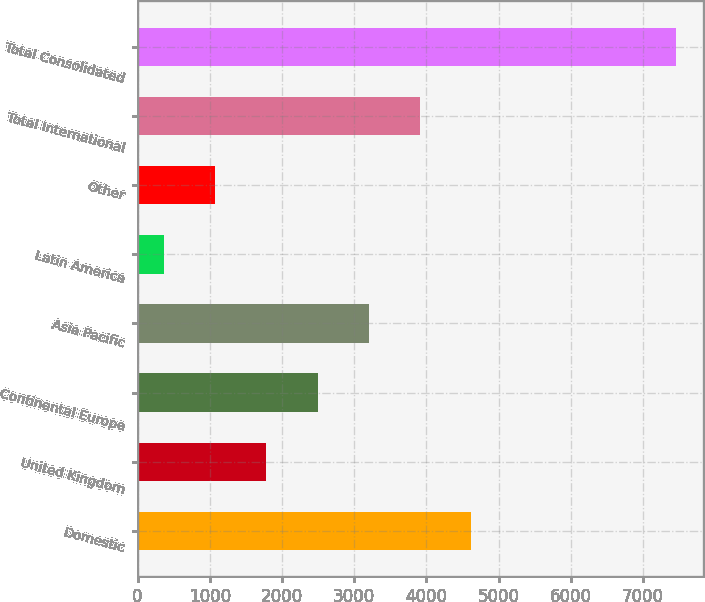Convert chart. <chart><loc_0><loc_0><loc_500><loc_500><bar_chart><fcel>Domestic<fcel>United Kingdom<fcel>Continental Europe<fcel>Asia Pacific<fcel>Latin America<fcel>Other<fcel>Total International<fcel>Total Consolidated<nl><fcel>4618.5<fcel>1784.7<fcel>2493.15<fcel>3201.6<fcel>367.8<fcel>1076.25<fcel>3910.05<fcel>7452.3<nl></chart> 